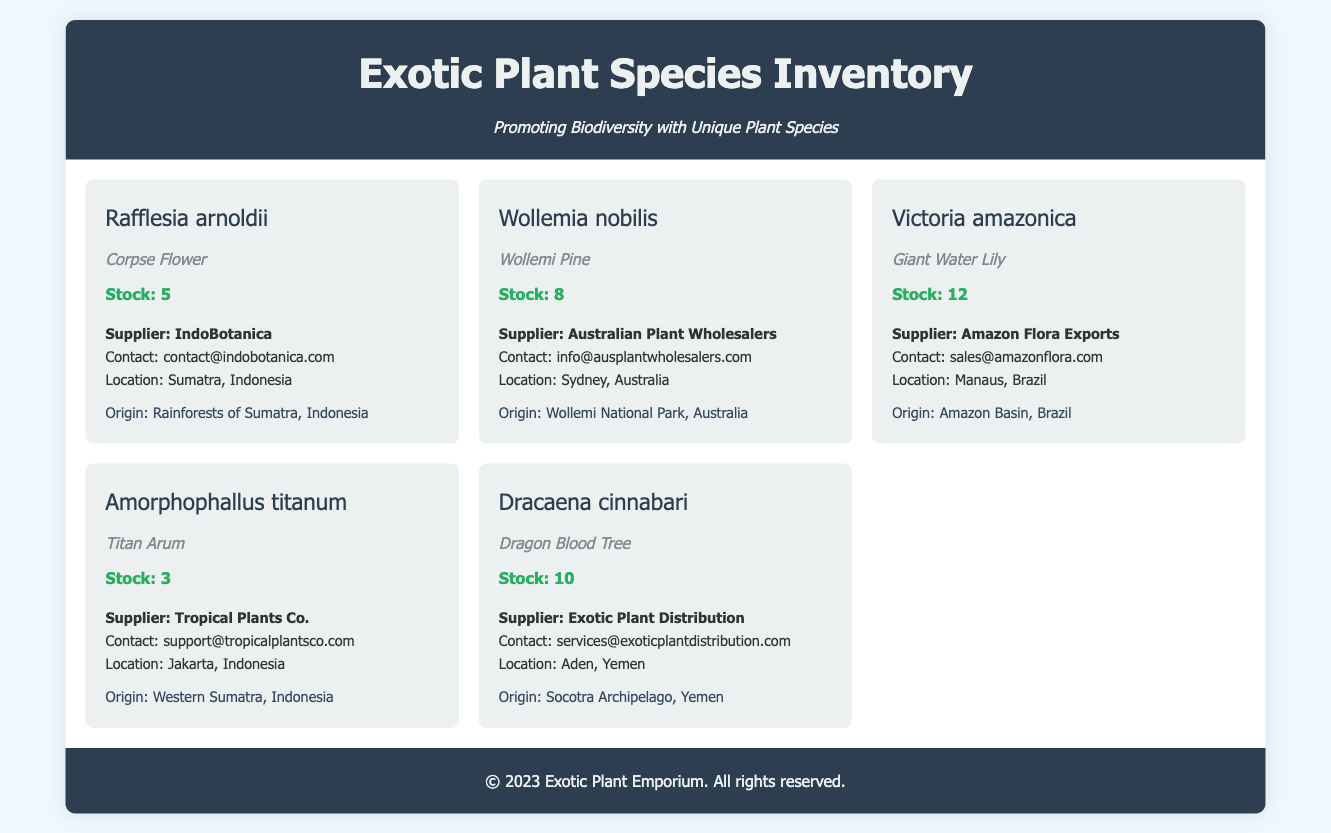What is the stock level of Rafflesia arnoldii? The stock level for Rafflesia arnoldii is specified in the document.
Answer: 5 Who is the supplier of Dracaena cinnabari? The supplier name for Dracaena cinnabari is provided as part of the supplier information.
Answer: Exotic Plant Distribution What is the origin of Victoria amazonica? The origin of Victoria amazonica is detailed in the document as part of the plant information.
Answer: Amazon Basin, Brazil How many Wollemi Pines are in stock? The stock level for Wollemi nobilis is stated in the inventory section.
Answer: 8 Which plant species has the common name 'Titan Arum'? The common name associated with Amorphophallus titanum is included in the details.
Answer: Titan Arum What is the contact email for the supplier of the Corpse Flower? The supplier contact email for Rafflesia arnoldii is listed in the document.
Answer: contact@indobotanica.com Which plant species has the highest stock level? Reasoning about the stock levels of all plant species reveals which has the most.
Answer: Victoria amazonica How many suppliers are listed in the inventory? Counting the suppliers mentioned in the document will give the total.
Answer: 5 What type of document is this? The structure and content of the document suggest its specific purpose and format.
Answer: Datasheet 